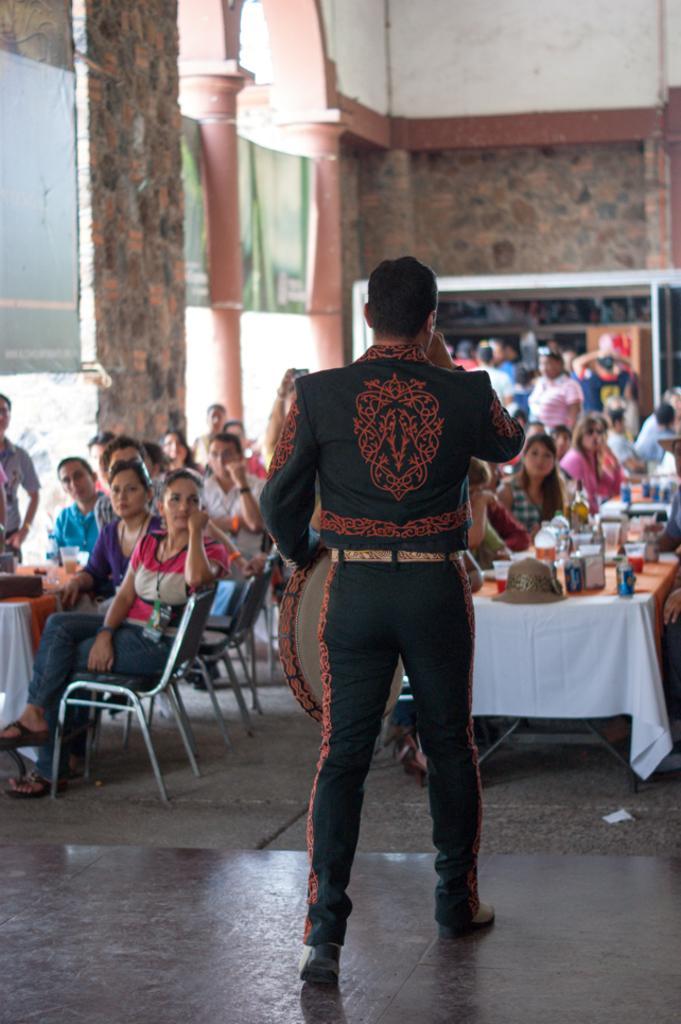In one or two sentences, can you explain what this image depicts? In this image we can see people sitting and standing. There are tables and we can see things placed on the tables. In the background there is a wall and we can see pillars. 